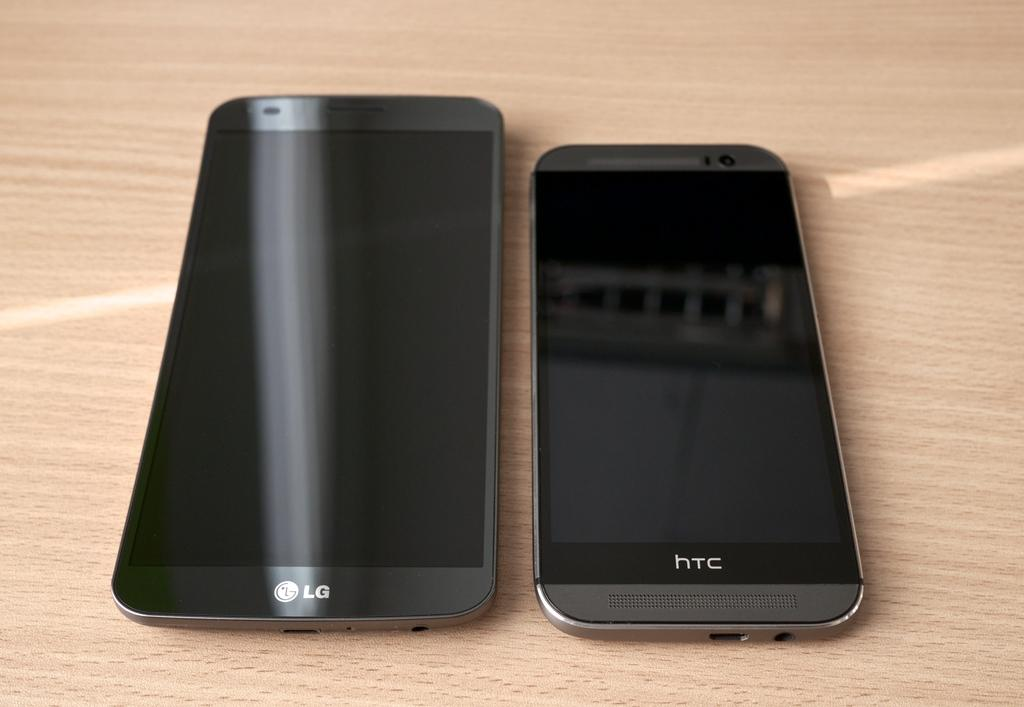Provide a one-sentence caption for the provided image. An LG phone lies on a table next to a HTC phone. 